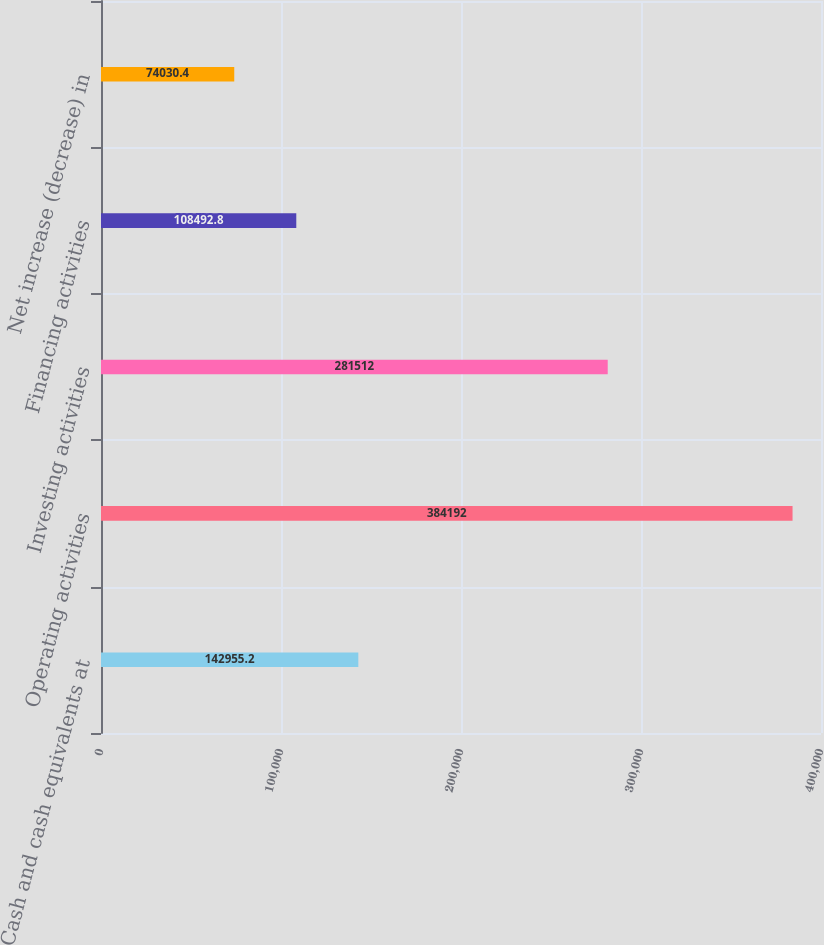<chart> <loc_0><loc_0><loc_500><loc_500><bar_chart><fcel>Cash and cash equivalents at<fcel>Operating activities<fcel>Investing activities<fcel>Financing activities<fcel>Net increase (decrease) in<nl><fcel>142955<fcel>384192<fcel>281512<fcel>108493<fcel>74030.4<nl></chart> 